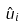<formula> <loc_0><loc_0><loc_500><loc_500>\hat { u } _ { i }</formula> 